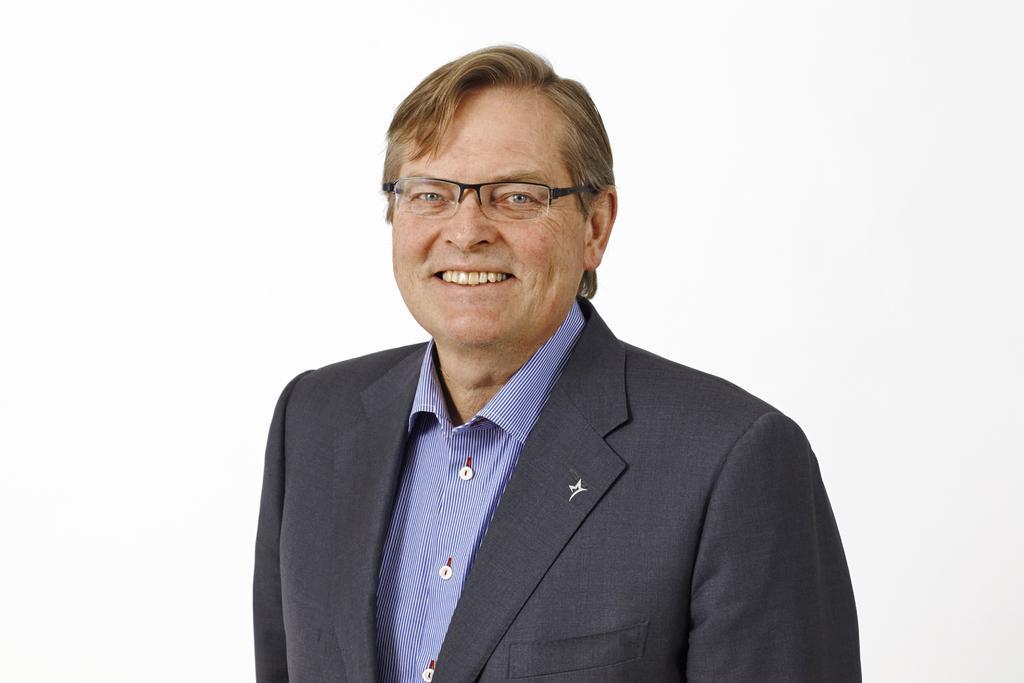In one or two sentences, can you explain what this image depicts? In this image I can see a person is smiling and wearing purple and black color dress. Background is in white color. 